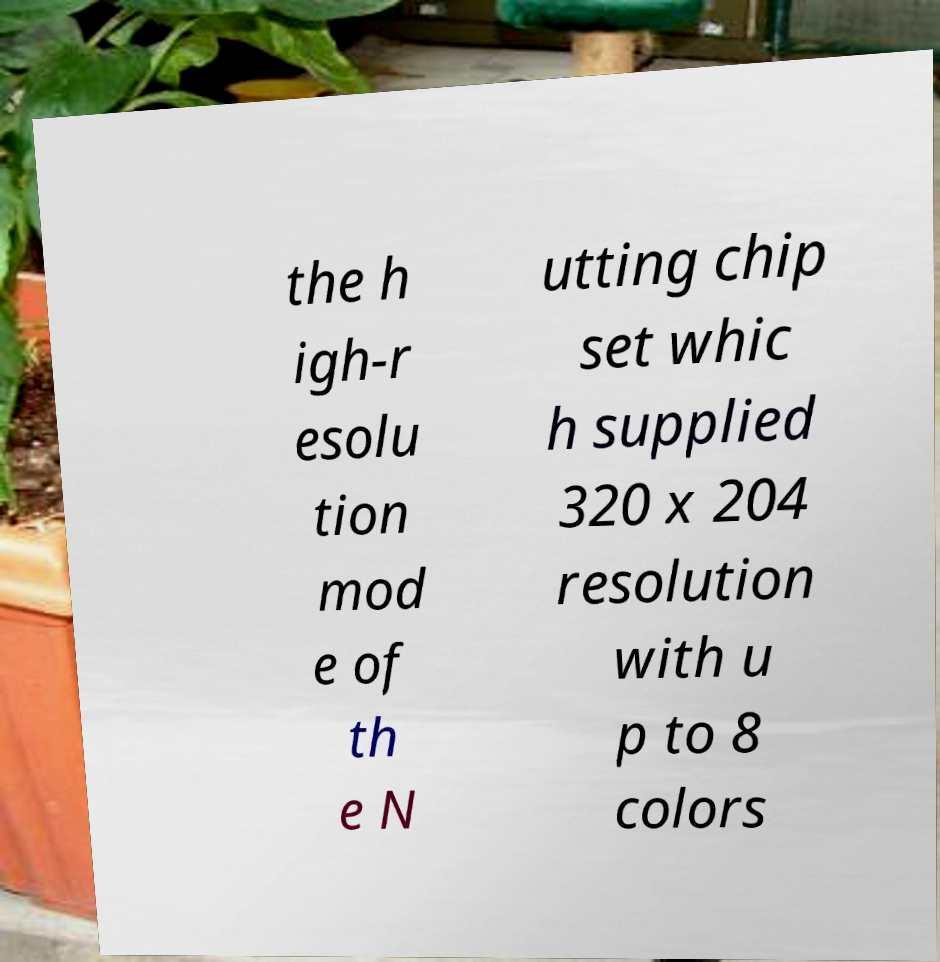There's text embedded in this image that I need extracted. Can you transcribe it verbatim? the h igh-r esolu tion mod e of th e N utting chip set whic h supplied 320 x 204 resolution with u p to 8 colors 